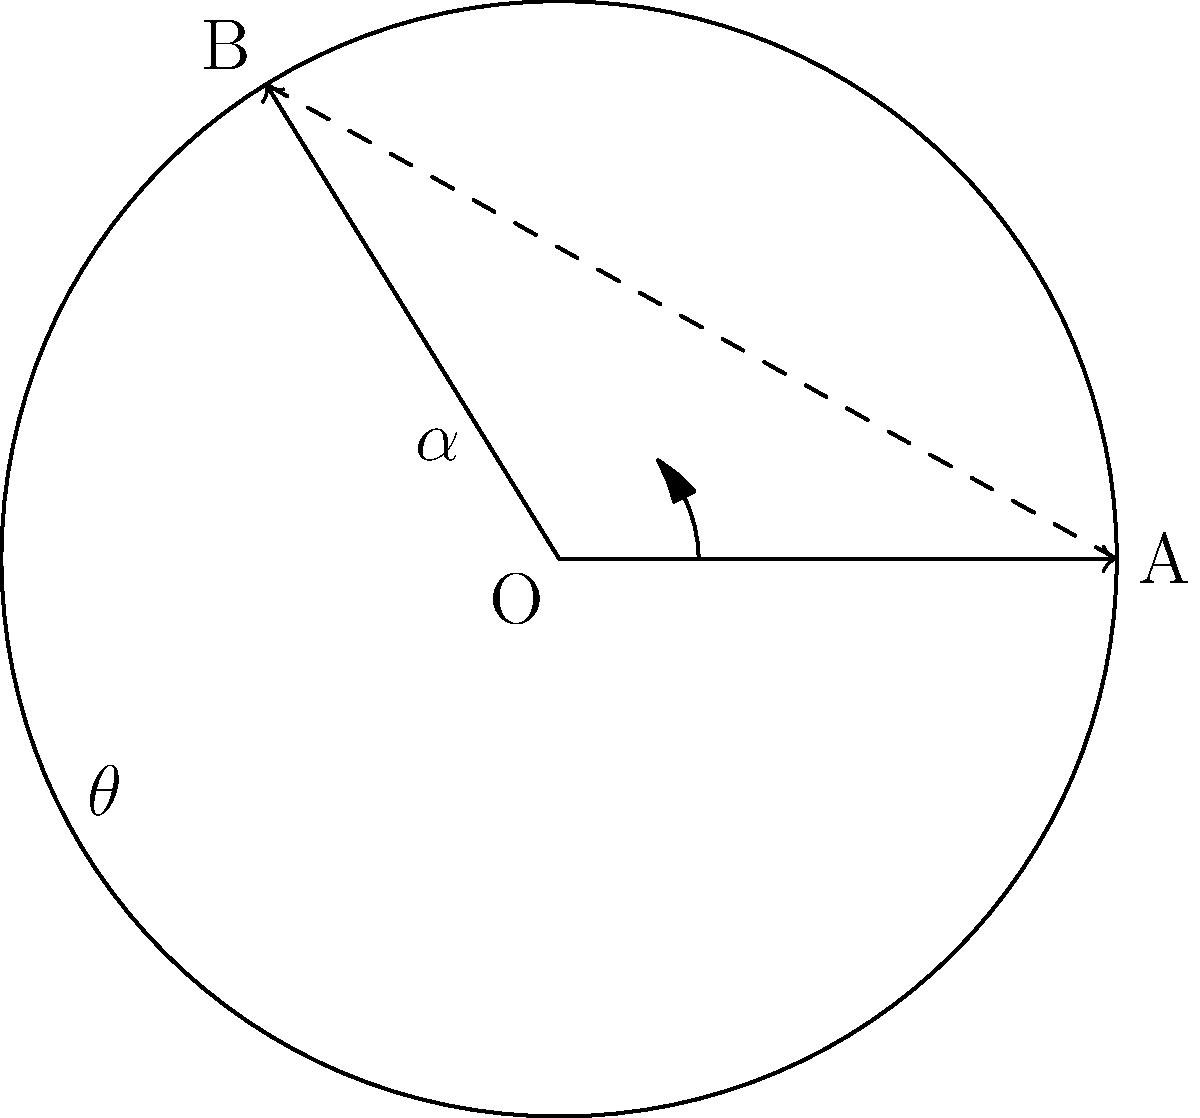In a curved fresco restoration project, you're analyzing the angle of incidence for light on the surface. The fresco has a circular cross-section with radius $r$. A light ray originating from the center O strikes the surface at point A and reflects to point B, forming an angle $\theta = 45°$ with OA. What is the angle of incidence $\alpha$ of the light ray on the fresco surface at point A? Let's approach this step-by-step:

1) In a circle, the tangent line at any point is perpendicular to the radius at that point. Therefore, the normal line at point A is along OA.

2) The angle of incidence is the angle between the incident ray and the normal line. In this case, it's the angle between OA and the tangent line at A.

3) The reflected ray makes the same angle with the normal as the incident ray. This is the law of reflection.

4) We're given that angle BOA is 45°. This means that the reflected ray makes a 45° angle with the normal (OA).

5) Since the incident angle equals the reflected angle, the angle of incidence $\alpha$ must also be 45°.

6) We can verify this: 
   - The incident ray is along OA
   - The reflected ray makes a 45° angle with OA
   - The total angle between the incident and reflected rays is 90°
   - This 90° is divided equally between the incident and reflected angles

Therefore, the angle of incidence $\alpha$ is 45°.
Answer: $\alpha = 45°$ 